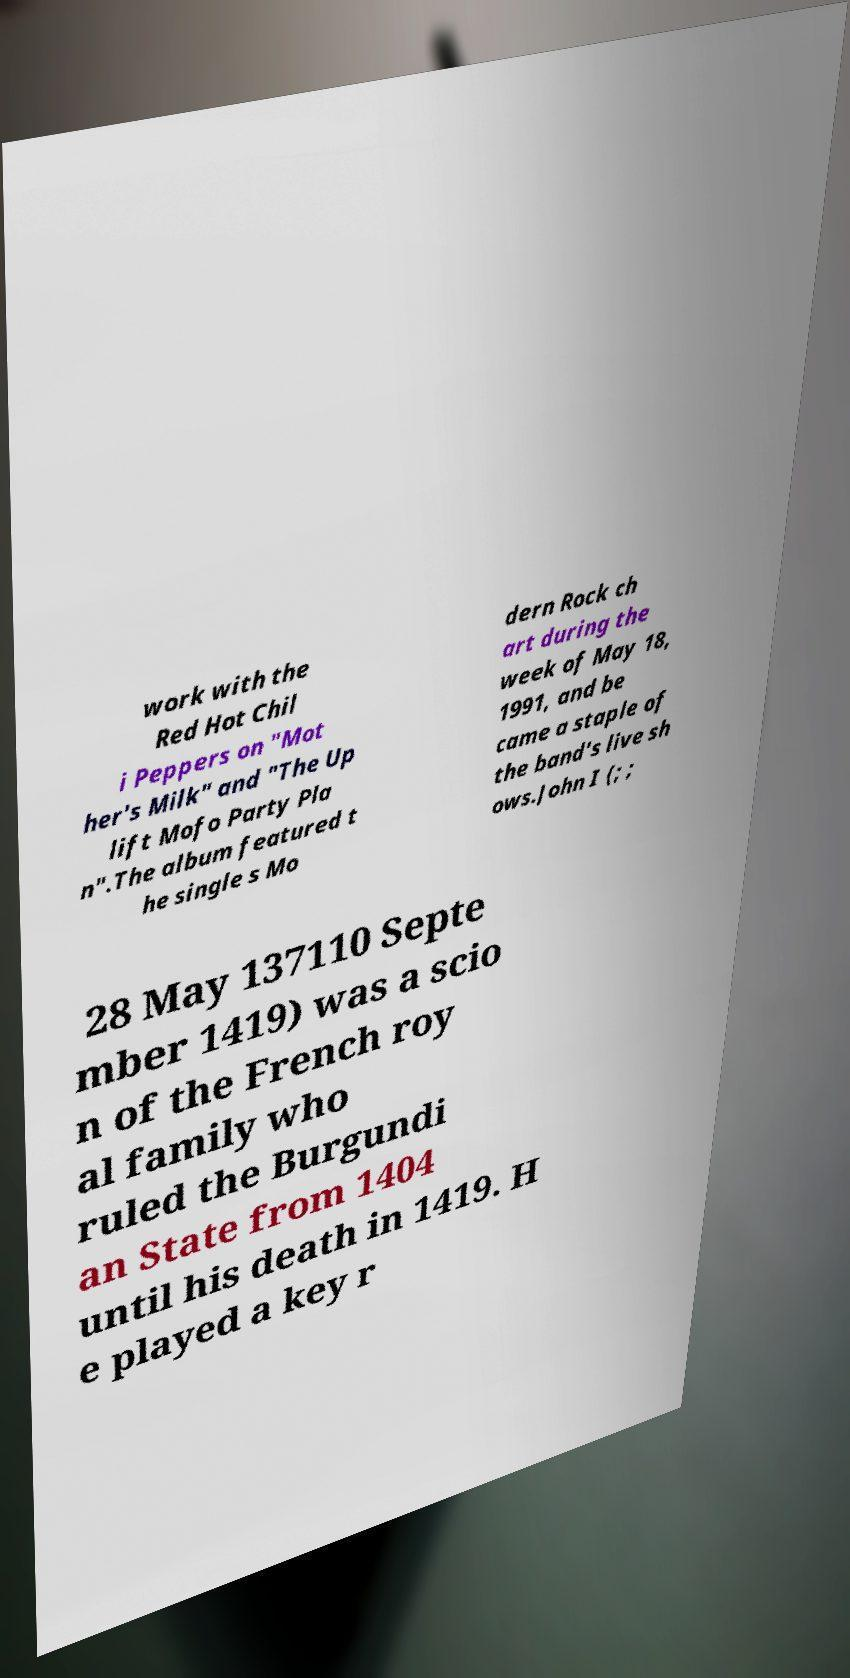What messages or text are displayed in this image? I need them in a readable, typed format. work with the Red Hot Chil i Peppers on "Mot her's Milk" and "The Up lift Mofo Party Pla n".The album featured t he single s Mo dern Rock ch art during the week of May 18, 1991, and be came a staple of the band's live sh ows.John I (; ; 28 May 137110 Septe mber 1419) was a scio n of the French roy al family who ruled the Burgundi an State from 1404 until his death in 1419. H e played a key r 